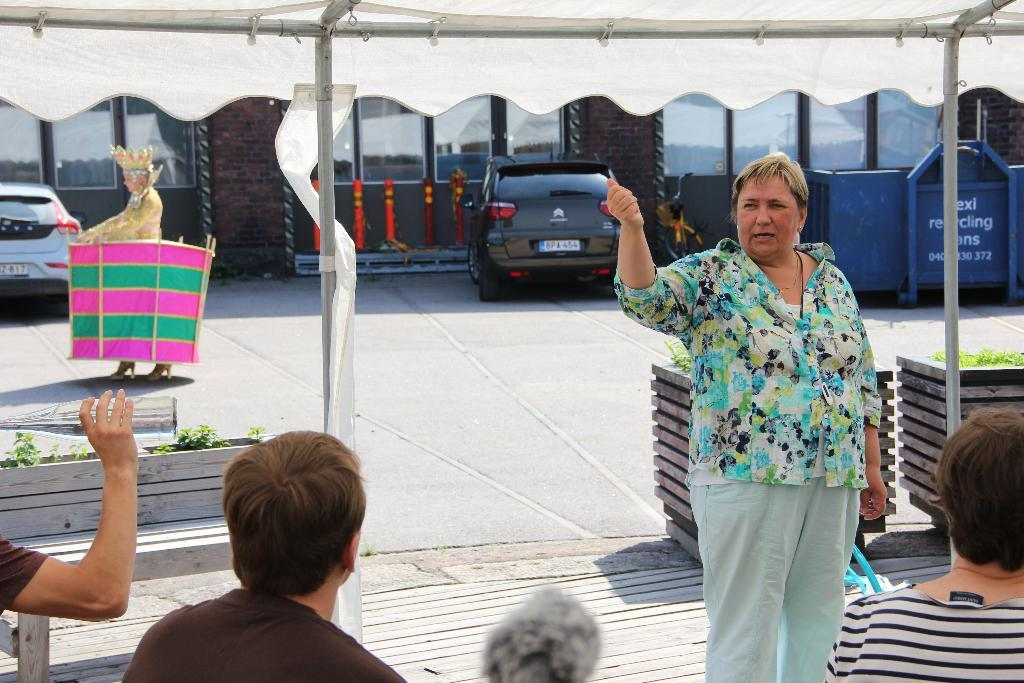How many people are in the image? There are people in the image, but the exact number is not specified. What structure can be seen in the image? There is a tent in the image. What are the poles used for in the image? The poles are likely used to support the tent. What type of vegetation is present in the image? There are plants in the image. What is the purpose of the road in the image? The road is likely used for transportation. What type of vehicles can be seen in the image? There are vehicles in the image, but the specific types are not mentioned. What part of a building can be seen in the image? There are windows and walls in the image. What objects are present in the image? There are objects in the image, but their specific nature is not described. What is the person holding in the image? One person is holding a bottle. How many people are in the crowd in the image? There is no mention of a crowd in the image, so it is not possible to determine the number of people in a crowd. 